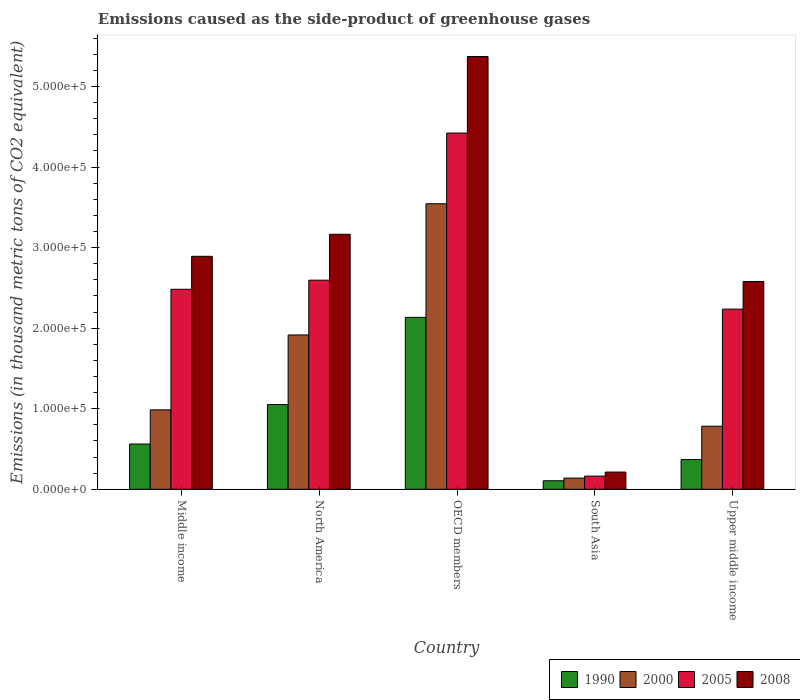How many bars are there on the 2nd tick from the left?
Offer a very short reply. 4. How many bars are there on the 4th tick from the right?
Keep it short and to the point. 4. What is the label of the 1st group of bars from the left?
Offer a terse response. Middle income. In how many cases, is the number of bars for a given country not equal to the number of legend labels?
Give a very brief answer. 0. What is the emissions caused as the side-product of greenhouse gases in 1990 in Upper middle income?
Provide a short and direct response. 3.69e+04. Across all countries, what is the maximum emissions caused as the side-product of greenhouse gases in 2008?
Your response must be concise. 5.37e+05. Across all countries, what is the minimum emissions caused as the side-product of greenhouse gases in 1990?
Make the answer very short. 1.06e+04. In which country was the emissions caused as the side-product of greenhouse gases in 2000 maximum?
Ensure brevity in your answer.  OECD members. In which country was the emissions caused as the side-product of greenhouse gases in 2000 minimum?
Your answer should be very brief. South Asia. What is the total emissions caused as the side-product of greenhouse gases in 1990 in the graph?
Give a very brief answer. 4.22e+05. What is the difference between the emissions caused as the side-product of greenhouse gases in 2000 in North America and that in South Asia?
Keep it short and to the point. 1.78e+05. What is the difference between the emissions caused as the side-product of greenhouse gases in 2000 in North America and the emissions caused as the side-product of greenhouse gases in 2005 in Upper middle income?
Provide a short and direct response. -3.21e+04. What is the average emissions caused as the side-product of greenhouse gases in 2008 per country?
Your answer should be compact. 2.84e+05. What is the difference between the emissions caused as the side-product of greenhouse gases of/in 1990 and emissions caused as the side-product of greenhouse gases of/in 2008 in Middle income?
Your answer should be compact. -2.33e+05. In how many countries, is the emissions caused as the side-product of greenhouse gases in 2005 greater than 20000 thousand metric tons?
Keep it short and to the point. 4. What is the ratio of the emissions caused as the side-product of greenhouse gases in 2005 in Middle income to that in Upper middle income?
Give a very brief answer. 1.11. Is the emissions caused as the side-product of greenhouse gases in 2005 in South Asia less than that in Upper middle income?
Provide a succinct answer. Yes. What is the difference between the highest and the second highest emissions caused as the side-product of greenhouse gases in 2005?
Provide a short and direct response. 1.13e+04. What is the difference between the highest and the lowest emissions caused as the side-product of greenhouse gases in 2005?
Your answer should be very brief. 4.26e+05. Is the sum of the emissions caused as the side-product of greenhouse gases in 1990 in North America and Upper middle income greater than the maximum emissions caused as the side-product of greenhouse gases in 2008 across all countries?
Keep it short and to the point. No. Are all the bars in the graph horizontal?
Keep it short and to the point. No. How many countries are there in the graph?
Your response must be concise. 5. Are the values on the major ticks of Y-axis written in scientific E-notation?
Keep it short and to the point. Yes. Where does the legend appear in the graph?
Make the answer very short. Bottom right. How are the legend labels stacked?
Your answer should be very brief. Horizontal. What is the title of the graph?
Your answer should be very brief. Emissions caused as the side-product of greenhouse gases. What is the label or title of the Y-axis?
Offer a very short reply. Emissions (in thousand metric tons of CO2 equivalent). What is the Emissions (in thousand metric tons of CO2 equivalent) in 1990 in Middle income?
Provide a short and direct response. 5.62e+04. What is the Emissions (in thousand metric tons of CO2 equivalent) in 2000 in Middle income?
Ensure brevity in your answer.  9.86e+04. What is the Emissions (in thousand metric tons of CO2 equivalent) in 2005 in Middle income?
Offer a very short reply. 2.48e+05. What is the Emissions (in thousand metric tons of CO2 equivalent) in 2008 in Middle income?
Provide a short and direct response. 2.89e+05. What is the Emissions (in thousand metric tons of CO2 equivalent) of 1990 in North America?
Your answer should be very brief. 1.05e+05. What is the Emissions (in thousand metric tons of CO2 equivalent) of 2000 in North America?
Your answer should be compact. 1.92e+05. What is the Emissions (in thousand metric tons of CO2 equivalent) in 2005 in North America?
Offer a very short reply. 2.60e+05. What is the Emissions (in thousand metric tons of CO2 equivalent) in 2008 in North America?
Your response must be concise. 3.17e+05. What is the Emissions (in thousand metric tons of CO2 equivalent) in 1990 in OECD members?
Offer a very short reply. 2.13e+05. What is the Emissions (in thousand metric tons of CO2 equivalent) in 2000 in OECD members?
Your response must be concise. 3.54e+05. What is the Emissions (in thousand metric tons of CO2 equivalent) in 2005 in OECD members?
Offer a very short reply. 4.42e+05. What is the Emissions (in thousand metric tons of CO2 equivalent) of 2008 in OECD members?
Ensure brevity in your answer.  5.37e+05. What is the Emissions (in thousand metric tons of CO2 equivalent) of 1990 in South Asia?
Your answer should be very brief. 1.06e+04. What is the Emissions (in thousand metric tons of CO2 equivalent) of 2000 in South Asia?
Ensure brevity in your answer.  1.39e+04. What is the Emissions (in thousand metric tons of CO2 equivalent) of 2005 in South Asia?
Keep it short and to the point. 1.64e+04. What is the Emissions (in thousand metric tons of CO2 equivalent) of 2008 in South Asia?
Provide a succinct answer. 2.14e+04. What is the Emissions (in thousand metric tons of CO2 equivalent) in 1990 in Upper middle income?
Make the answer very short. 3.69e+04. What is the Emissions (in thousand metric tons of CO2 equivalent) of 2000 in Upper middle income?
Your answer should be compact. 7.83e+04. What is the Emissions (in thousand metric tons of CO2 equivalent) in 2005 in Upper middle income?
Your answer should be compact. 2.24e+05. What is the Emissions (in thousand metric tons of CO2 equivalent) of 2008 in Upper middle income?
Offer a very short reply. 2.58e+05. Across all countries, what is the maximum Emissions (in thousand metric tons of CO2 equivalent) of 1990?
Offer a terse response. 2.13e+05. Across all countries, what is the maximum Emissions (in thousand metric tons of CO2 equivalent) in 2000?
Give a very brief answer. 3.54e+05. Across all countries, what is the maximum Emissions (in thousand metric tons of CO2 equivalent) of 2005?
Your answer should be compact. 4.42e+05. Across all countries, what is the maximum Emissions (in thousand metric tons of CO2 equivalent) in 2008?
Provide a short and direct response. 5.37e+05. Across all countries, what is the minimum Emissions (in thousand metric tons of CO2 equivalent) of 1990?
Offer a terse response. 1.06e+04. Across all countries, what is the minimum Emissions (in thousand metric tons of CO2 equivalent) of 2000?
Make the answer very short. 1.39e+04. Across all countries, what is the minimum Emissions (in thousand metric tons of CO2 equivalent) in 2005?
Provide a short and direct response. 1.64e+04. Across all countries, what is the minimum Emissions (in thousand metric tons of CO2 equivalent) of 2008?
Your answer should be compact. 2.14e+04. What is the total Emissions (in thousand metric tons of CO2 equivalent) of 1990 in the graph?
Provide a succinct answer. 4.22e+05. What is the total Emissions (in thousand metric tons of CO2 equivalent) in 2000 in the graph?
Provide a short and direct response. 7.37e+05. What is the total Emissions (in thousand metric tons of CO2 equivalent) of 2005 in the graph?
Provide a short and direct response. 1.19e+06. What is the total Emissions (in thousand metric tons of CO2 equivalent) in 2008 in the graph?
Ensure brevity in your answer.  1.42e+06. What is the difference between the Emissions (in thousand metric tons of CO2 equivalent) of 1990 in Middle income and that in North America?
Offer a very short reply. -4.90e+04. What is the difference between the Emissions (in thousand metric tons of CO2 equivalent) in 2000 in Middle income and that in North America?
Provide a short and direct response. -9.30e+04. What is the difference between the Emissions (in thousand metric tons of CO2 equivalent) in 2005 in Middle income and that in North America?
Ensure brevity in your answer.  -1.13e+04. What is the difference between the Emissions (in thousand metric tons of CO2 equivalent) of 2008 in Middle income and that in North America?
Your answer should be compact. -2.73e+04. What is the difference between the Emissions (in thousand metric tons of CO2 equivalent) in 1990 in Middle income and that in OECD members?
Your answer should be very brief. -1.57e+05. What is the difference between the Emissions (in thousand metric tons of CO2 equivalent) in 2000 in Middle income and that in OECD members?
Provide a succinct answer. -2.56e+05. What is the difference between the Emissions (in thousand metric tons of CO2 equivalent) in 2005 in Middle income and that in OECD members?
Keep it short and to the point. -1.94e+05. What is the difference between the Emissions (in thousand metric tons of CO2 equivalent) in 2008 in Middle income and that in OECD members?
Your answer should be compact. -2.48e+05. What is the difference between the Emissions (in thousand metric tons of CO2 equivalent) in 1990 in Middle income and that in South Asia?
Ensure brevity in your answer.  4.56e+04. What is the difference between the Emissions (in thousand metric tons of CO2 equivalent) of 2000 in Middle income and that in South Asia?
Make the answer very short. 8.47e+04. What is the difference between the Emissions (in thousand metric tons of CO2 equivalent) of 2005 in Middle income and that in South Asia?
Your answer should be compact. 2.32e+05. What is the difference between the Emissions (in thousand metric tons of CO2 equivalent) in 2008 in Middle income and that in South Asia?
Provide a short and direct response. 2.68e+05. What is the difference between the Emissions (in thousand metric tons of CO2 equivalent) in 1990 in Middle income and that in Upper middle income?
Keep it short and to the point. 1.93e+04. What is the difference between the Emissions (in thousand metric tons of CO2 equivalent) of 2000 in Middle income and that in Upper middle income?
Ensure brevity in your answer.  2.03e+04. What is the difference between the Emissions (in thousand metric tons of CO2 equivalent) of 2005 in Middle income and that in Upper middle income?
Your response must be concise. 2.47e+04. What is the difference between the Emissions (in thousand metric tons of CO2 equivalent) in 2008 in Middle income and that in Upper middle income?
Your response must be concise. 3.13e+04. What is the difference between the Emissions (in thousand metric tons of CO2 equivalent) of 1990 in North America and that in OECD members?
Your answer should be very brief. -1.08e+05. What is the difference between the Emissions (in thousand metric tons of CO2 equivalent) in 2000 in North America and that in OECD members?
Offer a terse response. -1.63e+05. What is the difference between the Emissions (in thousand metric tons of CO2 equivalent) in 2005 in North America and that in OECD members?
Your answer should be compact. -1.83e+05. What is the difference between the Emissions (in thousand metric tons of CO2 equivalent) in 2008 in North America and that in OECD members?
Give a very brief answer. -2.21e+05. What is the difference between the Emissions (in thousand metric tons of CO2 equivalent) of 1990 in North America and that in South Asia?
Provide a short and direct response. 9.46e+04. What is the difference between the Emissions (in thousand metric tons of CO2 equivalent) of 2000 in North America and that in South Asia?
Offer a very short reply. 1.78e+05. What is the difference between the Emissions (in thousand metric tons of CO2 equivalent) in 2005 in North America and that in South Asia?
Your response must be concise. 2.43e+05. What is the difference between the Emissions (in thousand metric tons of CO2 equivalent) of 2008 in North America and that in South Asia?
Make the answer very short. 2.95e+05. What is the difference between the Emissions (in thousand metric tons of CO2 equivalent) of 1990 in North America and that in Upper middle income?
Provide a short and direct response. 6.83e+04. What is the difference between the Emissions (in thousand metric tons of CO2 equivalent) of 2000 in North America and that in Upper middle income?
Your answer should be very brief. 1.13e+05. What is the difference between the Emissions (in thousand metric tons of CO2 equivalent) of 2005 in North America and that in Upper middle income?
Offer a very short reply. 3.59e+04. What is the difference between the Emissions (in thousand metric tons of CO2 equivalent) in 2008 in North America and that in Upper middle income?
Keep it short and to the point. 5.86e+04. What is the difference between the Emissions (in thousand metric tons of CO2 equivalent) of 1990 in OECD members and that in South Asia?
Offer a very short reply. 2.03e+05. What is the difference between the Emissions (in thousand metric tons of CO2 equivalent) in 2000 in OECD members and that in South Asia?
Ensure brevity in your answer.  3.41e+05. What is the difference between the Emissions (in thousand metric tons of CO2 equivalent) in 2005 in OECD members and that in South Asia?
Your answer should be compact. 4.26e+05. What is the difference between the Emissions (in thousand metric tons of CO2 equivalent) in 2008 in OECD members and that in South Asia?
Offer a terse response. 5.16e+05. What is the difference between the Emissions (in thousand metric tons of CO2 equivalent) in 1990 in OECD members and that in Upper middle income?
Your answer should be compact. 1.77e+05. What is the difference between the Emissions (in thousand metric tons of CO2 equivalent) of 2000 in OECD members and that in Upper middle income?
Your answer should be very brief. 2.76e+05. What is the difference between the Emissions (in thousand metric tons of CO2 equivalent) in 2005 in OECD members and that in Upper middle income?
Offer a very short reply. 2.19e+05. What is the difference between the Emissions (in thousand metric tons of CO2 equivalent) of 2008 in OECD members and that in Upper middle income?
Provide a short and direct response. 2.79e+05. What is the difference between the Emissions (in thousand metric tons of CO2 equivalent) of 1990 in South Asia and that in Upper middle income?
Provide a succinct answer. -2.63e+04. What is the difference between the Emissions (in thousand metric tons of CO2 equivalent) in 2000 in South Asia and that in Upper middle income?
Give a very brief answer. -6.44e+04. What is the difference between the Emissions (in thousand metric tons of CO2 equivalent) in 2005 in South Asia and that in Upper middle income?
Give a very brief answer. -2.07e+05. What is the difference between the Emissions (in thousand metric tons of CO2 equivalent) of 2008 in South Asia and that in Upper middle income?
Give a very brief answer. -2.37e+05. What is the difference between the Emissions (in thousand metric tons of CO2 equivalent) of 1990 in Middle income and the Emissions (in thousand metric tons of CO2 equivalent) of 2000 in North America?
Offer a terse response. -1.35e+05. What is the difference between the Emissions (in thousand metric tons of CO2 equivalent) in 1990 in Middle income and the Emissions (in thousand metric tons of CO2 equivalent) in 2005 in North America?
Make the answer very short. -2.03e+05. What is the difference between the Emissions (in thousand metric tons of CO2 equivalent) in 1990 in Middle income and the Emissions (in thousand metric tons of CO2 equivalent) in 2008 in North America?
Ensure brevity in your answer.  -2.60e+05. What is the difference between the Emissions (in thousand metric tons of CO2 equivalent) of 2000 in Middle income and the Emissions (in thousand metric tons of CO2 equivalent) of 2005 in North America?
Your answer should be compact. -1.61e+05. What is the difference between the Emissions (in thousand metric tons of CO2 equivalent) of 2000 in Middle income and the Emissions (in thousand metric tons of CO2 equivalent) of 2008 in North America?
Offer a very short reply. -2.18e+05. What is the difference between the Emissions (in thousand metric tons of CO2 equivalent) in 2005 in Middle income and the Emissions (in thousand metric tons of CO2 equivalent) in 2008 in North America?
Your answer should be compact. -6.83e+04. What is the difference between the Emissions (in thousand metric tons of CO2 equivalent) of 1990 in Middle income and the Emissions (in thousand metric tons of CO2 equivalent) of 2000 in OECD members?
Make the answer very short. -2.98e+05. What is the difference between the Emissions (in thousand metric tons of CO2 equivalent) of 1990 in Middle income and the Emissions (in thousand metric tons of CO2 equivalent) of 2005 in OECD members?
Ensure brevity in your answer.  -3.86e+05. What is the difference between the Emissions (in thousand metric tons of CO2 equivalent) in 1990 in Middle income and the Emissions (in thousand metric tons of CO2 equivalent) in 2008 in OECD members?
Keep it short and to the point. -4.81e+05. What is the difference between the Emissions (in thousand metric tons of CO2 equivalent) in 2000 in Middle income and the Emissions (in thousand metric tons of CO2 equivalent) in 2005 in OECD members?
Provide a short and direct response. -3.44e+05. What is the difference between the Emissions (in thousand metric tons of CO2 equivalent) of 2000 in Middle income and the Emissions (in thousand metric tons of CO2 equivalent) of 2008 in OECD members?
Give a very brief answer. -4.39e+05. What is the difference between the Emissions (in thousand metric tons of CO2 equivalent) of 2005 in Middle income and the Emissions (in thousand metric tons of CO2 equivalent) of 2008 in OECD members?
Give a very brief answer. -2.89e+05. What is the difference between the Emissions (in thousand metric tons of CO2 equivalent) of 1990 in Middle income and the Emissions (in thousand metric tons of CO2 equivalent) of 2000 in South Asia?
Your answer should be very brief. 4.23e+04. What is the difference between the Emissions (in thousand metric tons of CO2 equivalent) in 1990 in Middle income and the Emissions (in thousand metric tons of CO2 equivalent) in 2005 in South Asia?
Ensure brevity in your answer.  3.98e+04. What is the difference between the Emissions (in thousand metric tons of CO2 equivalent) of 1990 in Middle income and the Emissions (in thousand metric tons of CO2 equivalent) of 2008 in South Asia?
Your answer should be very brief. 3.48e+04. What is the difference between the Emissions (in thousand metric tons of CO2 equivalent) in 2000 in Middle income and the Emissions (in thousand metric tons of CO2 equivalent) in 2005 in South Asia?
Make the answer very short. 8.22e+04. What is the difference between the Emissions (in thousand metric tons of CO2 equivalent) in 2000 in Middle income and the Emissions (in thousand metric tons of CO2 equivalent) in 2008 in South Asia?
Your answer should be very brief. 7.72e+04. What is the difference between the Emissions (in thousand metric tons of CO2 equivalent) in 2005 in Middle income and the Emissions (in thousand metric tons of CO2 equivalent) in 2008 in South Asia?
Your response must be concise. 2.27e+05. What is the difference between the Emissions (in thousand metric tons of CO2 equivalent) in 1990 in Middle income and the Emissions (in thousand metric tons of CO2 equivalent) in 2000 in Upper middle income?
Provide a succinct answer. -2.21e+04. What is the difference between the Emissions (in thousand metric tons of CO2 equivalent) in 1990 in Middle income and the Emissions (in thousand metric tons of CO2 equivalent) in 2005 in Upper middle income?
Your answer should be compact. -1.67e+05. What is the difference between the Emissions (in thousand metric tons of CO2 equivalent) of 1990 in Middle income and the Emissions (in thousand metric tons of CO2 equivalent) of 2008 in Upper middle income?
Ensure brevity in your answer.  -2.02e+05. What is the difference between the Emissions (in thousand metric tons of CO2 equivalent) in 2000 in Middle income and the Emissions (in thousand metric tons of CO2 equivalent) in 2005 in Upper middle income?
Offer a very short reply. -1.25e+05. What is the difference between the Emissions (in thousand metric tons of CO2 equivalent) in 2000 in Middle income and the Emissions (in thousand metric tons of CO2 equivalent) in 2008 in Upper middle income?
Ensure brevity in your answer.  -1.59e+05. What is the difference between the Emissions (in thousand metric tons of CO2 equivalent) in 2005 in Middle income and the Emissions (in thousand metric tons of CO2 equivalent) in 2008 in Upper middle income?
Your answer should be compact. -9667. What is the difference between the Emissions (in thousand metric tons of CO2 equivalent) in 1990 in North America and the Emissions (in thousand metric tons of CO2 equivalent) in 2000 in OECD members?
Ensure brevity in your answer.  -2.49e+05. What is the difference between the Emissions (in thousand metric tons of CO2 equivalent) of 1990 in North America and the Emissions (in thousand metric tons of CO2 equivalent) of 2005 in OECD members?
Provide a succinct answer. -3.37e+05. What is the difference between the Emissions (in thousand metric tons of CO2 equivalent) of 1990 in North America and the Emissions (in thousand metric tons of CO2 equivalent) of 2008 in OECD members?
Provide a succinct answer. -4.32e+05. What is the difference between the Emissions (in thousand metric tons of CO2 equivalent) of 2000 in North America and the Emissions (in thousand metric tons of CO2 equivalent) of 2005 in OECD members?
Your answer should be very brief. -2.51e+05. What is the difference between the Emissions (in thousand metric tons of CO2 equivalent) of 2000 in North America and the Emissions (in thousand metric tons of CO2 equivalent) of 2008 in OECD members?
Keep it short and to the point. -3.46e+05. What is the difference between the Emissions (in thousand metric tons of CO2 equivalent) in 2005 in North America and the Emissions (in thousand metric tons of CO2 equivalent) in 2008 in OECD members?
Offer a terse response. -2.78e+05. What is the difference between the Emissions (in thousand metric tons of CO2 equivalent) in 1990 in North America and the Emissions (in thousand metric tons of CO2 equivalent) in 2000 in South Asia?
Give a very brief answer. 9.13e+04. What is the difference between the Emissions (in thousand metric tons of CO2 equivalent) of 1990 in North America and the Emissions (in thousand metric tons of CO2 equivalent) of 2005 in South Asia?
Offer a terse response. 8.88e+04. What is the difference between the Emissions (in thousand metric tons of CO2 equivalent) of 1990 in North America and the Emissions (in thousand metric tons of CO2 equivalent) of 2008 in South Asia?
Provide a short and direct response. 8.38e+04. What is the difference between the Emissions (in thousand metric tons of CO2 equivalent) in 2000 in North America and the Emissions (in thousand metric tons of CO2 equivalent) in 2005 in South Asia?
Offer a very short reply. 1.75e+05. What is the difference between the Emissions (in thousand metric tons of CO2 equivalent) in 2000 in North America and the Emissions (in thousand metric tons of CO2 equivalent) in 2008 in South Asia?
Your answer should be very brief. 1.70e+05. What is the difference between the Emissions (in thousand metric tons of CO2 equivalent) in 2005 in North America and the Emissions (in thousand metric tons of CO2 equivalent) in 2008 in South Asia?
Provide a short and direct response. 2.38e+05. What is the difference between the Emissions (in thousand metric tons of CO2 equivalent) in 1990 in North America and the Emissions (in thousand metric tons of CO2 equivalent) in 2000 in Upper middle income?
Your response must be concise. 2.69e+04. What is the difference between the Emissions (in thousand metric tons of CO2 equivalent) of 1990 in North America and the Emissions (in thousand metric tons of CO2 equivalent) of 2005 in Upper middle income?
Keep it short and to the point. -1.18e+05. What is the difference between the Emissions (in thousand metric tons of CO2 equivalent) in 1990 in North America and the Emissions (in thousand metric tons of CO2 equivalent) in 2008 in Upper middle income?
Make the answer very short. -1.53e+05. What is the difference between the Emissions (in thousand metric tons of CO2 equivalent) of 2000 in North America and the Emissions (in thousand metric tons of CO2 equivalent) of 2005 in Upper middle income?
Offer a very short reply. -3.21e+04. What is the difference between the Emissions (in thousand metric tons of CO2 equivalent) of 2000 in North America and the Emissions (in thousand metric tons of CO2 equivalent) of 2008 in Upper middle income?
Ensure brevity in your answer.  -6.64e+04. What is the difference between the Emissions (in thousand metric tons of CO2 equivalent) in 2005 in North America and the Emissions (in thousand metric tons of CO2 equivalent) in 2008 in Upper middle income?
Offer a very short reply. 1628.2. What is the difference between the Emissions (in thousand metric tons of CO2 equivalent) of 1990 in OECD members and the Emissions (in thousand metric tons of CO2 equivalent) of 2000 in South Asia?
Make the answer very short. 2.00e+05. What is the difference between the Emissions (in thousand metric tons of CO2 equivalent) in 1990 in OECD members and the Emissions (in thousand metric tons of CO2 equivalent) in 2005 in South Asia?
Offer a very short reply. 1.97e+05. What is the difference between the Emissions (in thousand metric tons of CO2 equivalent) of 1990 in OECD members and the Emissions (in thousand metric tons of CO2 equivalent) of 2008 in South Asia?
Provide a succinct answer. 1.92e+05. What is the difference between the Emissions (in thousand metric tons of CO2 equivalent) in 2000 in OECD members and the Emissions (in thousand metric tons of CO2 equivalent) in 2005 in South Asia?
Your answer should be very brief. 3.38e+05. What is the difference between the Emissions (in thousand metric tons of CO2 equivalent) in 2000 in OECD members and the Emissions (in thousand metric tons of CO2 equivalent) in 2008 in South Asia?
Offer a terse response. 3.33e+05. What is the difference between the Emissions (in thousand metric tons of CO2 equivalent) of 2005 in OECD members and the Emissions (in thousand metric tons of CO2 equivalent) of 2008 in South Asia?
Provide a succinct answer. 4.21e+05. What is the difference between the Emissions (in thousand metric tons of CO2 equivalent) in 1990 in OECD members and the Emissions (in thousand metric tons of CO2 equivalent) in 2000 in Upper middle income?
Your response must be concise. 1.35e+05. What is the difference between the Emissions (in thousand metric tons of CO2 equivalent) in 1990 in OECD members and the Emissions (in thousand metric tons of CO2 equivalent) in 2005 in Upper middle income?
Ensure brevity in your answer.  -1.02e+04. What is the difference between the Emissions (in thousand metric tons of CO2 equivalent) of 1990 in OECD members and the Emissions (in thousand metric tons of CO2 equivalent) of 2008 in Upper middle income?
Offer a very short reply. -4.45e+04. What is the difference between the Emissions (in thousand metric tons of CO2 equivalent) of 2000 in OECD members and the Emissions (in thousand metric tons of CO2 equivalent) of 2005 in Upper middle income?
Keep it short and to the point. 1.31e+05. What is the difference between the Emissions (in thousand metric tons of CO2 equivalent) of 2000 in OECD members and the Emissions (in thousand metric tons of CO2 equivalent) of 2008 in Upper middle income?
Make the answer very short. 9.65e+04. What is the difference between the Emissions (in thousand metric tons of CO2 equivalent) of 2005 in OECD members and the Emissions (in thousand metric tons of CO2 equivalent) of 2008 in Upper middle income?
Your answer should be compact. 1.84e+05. What is the difference between the Emissions (in thousand metric tons of CO2 equivalent) of 1990 in South Asia and the Emissions (in thousand metric tons of CO2 equivalent) of 2000 in Upper middle income?
Your answer should be very brief. -6.77e+04. What is the difference between the Emissions (in thousand metric tons of CO2 equivalent) of 1990 in South Asia and the Emissions (in thousand metric tons of CO2 equivalent) of 2005 in Upper middle income?
Ensure brevity in your answer.  -2.13e+05. What is the difference between the Emissions (in thousand metric tons of CO2 equivalent) of 1990 in South Asia and the Emissions (in thousand metric tons of CO2 equivalent) of 2008 in Upper middle income?
Give a very brief answer. -2.47e+05. What is the difference between the Emissions (in thousand metric tons of CO2 equivalent) in 2000 in South Asia and the Emissions (in thousand metric tons of CO2 equivalent) in 2005 in Upper middle income?
Offer a very short reply. -2.10e+05. What is the difference between the Emissions (in thousand metric tons of CO2 equivalent) in 2000 in South Asia and the Emissions (in thousand metric tons of CO2 equivalent) in 2008 in Upper middle income?
Your response must be concise. -2.44e+05. What is the difference between the Emissions (in thousand metric tons of CO2 equivalent) in 2005 in South Asia and the Emissions (in thousand metric tons of CO2 equivalent) in 2008 in Upper middle income?
Provide a succinct answer. -2.42e+05. What is the average Emissions (in thousand metric tons of CO2 equivalent) of 1990 per country?
Offer a terse response. 8.45e+04. What is the average Emissions (in thousand metric tons of CO2 equivalent) of 2000 per country?
Your answer should be very brief. 1.47e+05. What is the average Emissions (in thousand metric tons of CO2 equivalent) of 2005 per country?
Provide a short and direct response. 2.38e+05. What is the average Emissions (in thousand metric tons of CO2 equivalent) of 2008 per country?
Ensure brevity in your answer.  2.84e+05. What is the difference between the Emissions (in thousand metric tons of CO2 equivalent) in 1990 and Emissions (in thousand metric tons of CO2 equivalent) in 2000 in Middle income?
Your answer should be very brief. -4.24e+04. What is the difference between the Emissions (in thousand metric tons of CO2 equivalent) of 1990 and Emissions (in thousand metric tons of CO2 equivalent) of 2005 in Middle income?
Provide a short and direct response. -1.92e+05. What is the difference between the Emissions (in thousand metric tons of CO2 equivalent) in 1990 and Emissions (in thousand metric tons of CO2 equivalent) in 2008 in Middle income?
Your answer should be compact. -2.33e+05. What is the difference between the Emissions (in thousand metric tons of CO2 equivalent) in 2000 and Emissions (in thousand metric tons of CO2 equivalent) in 2005 in Middle income?
Offer a terse response. -1.50e+05. What is the difference between the Emissions (in thousand metric tons of CO2 equivalent) of 2000 and Emissions (in thousand metric tons of CO2 equivalent) of 2008 in Middle income?
Make the answer very short. -1.91e+05. What is the difference between the Emissions (in thousand metric tons of CO2 equivalent) in 2005 and Emissions (in thousand metric tons of CO2 equivalent) in 2008 in Middle income?
Ensure brevity in your answer.  -4.09e+04. What is the difference between the Emissions (in thousand metric tons of CO2 equivalent) in 1990 and Emissions (in thousand metric tons of CO2 equivalent) in 2000 in North America?
Your answer should be compact. -8.64e+04. What is the difference between the Emissions (in thousand metric tons of CO2 equivalent) of 1990 and Emissions (in thousand metric tons of CO2 equivalent) of 2005 in North America?
Provide a short and direct response. -1.54e+05. What is the difference between the Emissions (in thousand metric tons of CO2 equivalent) of 1990 and Emissions (in thousand metric tons of CO2 equivalent) of 2008 in North America?
Make the answer very short. -2.11e+05. What is the difference between the Emissions (in thousand metric tons of CO2 equivalent) of 2000 and Emissions (in thousand metric tons of CO2 equivalent) of 2005 in North America?
Ensure brevity in your answer.  -6.80e+04. What is the difference between the Emissions (in thousand metric tons of CO2 equivalent) of 2000 and Emissions (in thousand metric tons of CO2 equivalent) of 2008 in North America?
Provide a short and direct response. -1.25e+05. What is the difference between the Emissions (in thousand metric tons of CO2 equivalent) in 2005 and Emissions (in thousand metric tons of CO2 equivalent) in 2008 in North America?
Your answer should be compact. -5.70e+04. What is the difference between the Emissions (in thousand metric tons of CO2 equivalent) in 1990 and Emissions (in thousand metric tons of CO2 equivalent) in 2000 in OECD members?
Provide a short and direct response. -1.41e+05. What is the difference between the Emissions (in thousand metric tons of CO2 equivalent) of 1990 and Emissions (in thousand metric tons of CO2 equivalent) of 2005 in OECD members?
Provide a succinct answer. -2.29e+05. What is the difference between the Emissions (in thousand metric tons of CO2 equivalent) in 1990 and Emissions (in thousand metric tons of CO2 equivalent) in 2008 in OECD members?
Provide a short and direct response. -3.24e+05. What is the difference between the Emissions (in thousand metric tons of CO2 equivalent) in 2000 and Emissions (in thousand metric tons of CO2 equivalent) in 2005 in OECD members?
Provide a short and direct response. -8.78e+04. What is the difference between the Emissions (in thousand metric tons of CO2 equivalent) of 2000 and Emissions (in thousand metric tons of CO2 equivalent) of 2008 in OECD members?
Your answer should be very brief. -1.83e+05. What is the difference between the Emissions (in thousand metric tons of CO2 equivalent) of 2005 and Emissions (in thousand metric tons of CO2 equivalent) of 2008 in OECD members?
Your answer should be compact. -9.50e+04. What is the difference between the Emissions (in thousand metric tons of CO2 equivalent) in 1990 and Emissions (in thousand metric tons of CO2 equivalent) in 2000 in South Asia?
Offer a terse response. -3325.3. What is the difference between the Emissions (in thousand metric tons of CO2 equivalent) in 1990 and Emissions (in thousand metric tons of CO2 equivalent) in 2005 in South Asia?
Provide a short and direct response. -5786.5. What is the difference between the Emissions (in thousand metric tons of CO2 equivalent) in 1990 and Emissions (in thousand metric tons of CO2 equivalent) in 2008 in South Asia?
Provide a succinct answer. -1.08e+04. What is the difference between the Emissions (in thousand metric tons of CO2 equivalent) of 2000 and Emissions (in thousand metric tons of CO2 equivalent) of 2005 in South Asia?
Give a very brief answer. -2461.2. What is the difference between the Emissions (in thousand metric tons of CO2 equivalent) of 2000 and Emissions (in thousand metric tons of CO2 equivalent) of 2008 in South Asia?
Keep it short and to the point. -7460.6. What is the difference between the Emissions (in thousand metric tons of CO2 equivalent) of 2005 and Emissions (in thousand metric tons of CO2 equivalent) of 2008 in South Asia?
Provide a succinct answer. -4999.4. What is the difference between the Emissions (in thousand metric tons of CO2 equivalent) of 1990 and Emissions (in thousand metric tons of CO2 equivalent) of 2000 in Upper middle income?
Your response must be concise. -4.14e+04. What is the difference between the Emissions (in thousand metric tons of CO2 equivalent) of 1990 and Emissions (in thousand metric tons of CO2 equivalent) of 2005 in Upper middle income?
Your answer should be compact. -1.87e+05. What is the difference between the Emissions (in thousand metric tons of CO2 equivalent) in 1990 and Emissions (in thousand metric tons of CO2 equivalent) in 2008 in Upper middle income?
Make the answer very short. -2.21e+05. What is the difference between the Emissions (in thousand metric tons of CO2 equivalent) of 2000 and Emissions (in thousand metric tons of CO2 equivalent) of 2005 in Upper middle income?
Offer a terse response. -1.45e+05. What is the difference between the Emissions (in thousand metric tons of CO2 equivalent) of 2000 and Emissions (in thousand metric tons of CO2 equivalent) of 2008 in Upper middle income?
Your answer should be very brief. -1.80e+05. What is the difference between the Emissions (in thousand metric tons of CO2 equivalent) in 2005 and Emissions (in thousand metric tons of CO2 equivalent) in 2008 in Upper middle income?
Offer a very short reply. -3.43e+04. What is the ratio of the Emissions (in thousand metric tons of CO2 equivalent) of 1990 in Middle income to that in North America?
Your answer should be very brief. 0.53. What is the ratio of the Emissions (in thousand metric tons of CO2 equivalent) of 2000 in Middle income to that in North America?
Make the answer very short. 0.51. What is the ratio of the Emissions (in thousand metric tons of CO2 equivalent) in 2005 in Middle income to that in North America?
Provide a short and direct response. 0.96. What is the ratio of the Emissions (in thousand metric tons of CO2 equivalent) of 2008 in Middle income to that in North America?
Make the answer very short. 0.91. What is the ratio of the Emissions (in thousand metric tons of CO2 equivalent) of 1990 in Middle income to that in OECD members?
Your response must be concise. 0.26. What is the ratio of the Emissions (in thousand metric tons of CO2 equivalent) of 2000 in Middle income to that in OECD members?
Make the answer very short. 0.28. What is the ratio of the Emissions (in thousand metric tons of CO2 equivalent) of 2005 in Middle income to that in OECD members?
Ensure brevity in your answer.  0.56. What is the ratio of the Emissions (in thousand metric tons of CO2 equivalent) in 2008 in Middle income to that in OECD members?
Ensure brevity in your answer.  0.54. What is the ratio of the Emissions (in thousand metric tons of CO2 equivalent) of 1990 in Middle income to that in South Asia?
Make the answer very short. 5.31. What is the ratio of the Emissions (in thousand metric tons of CO2 equivalent) in 2000 in Middle income to that in South Asia?
Your answer should be very brief. 7.09. What is the ratio of the Emissions (in thousand metric tons of CO2 equivalent) of 2005 in Middle income to that in South Asia?
Keep it short and to the point. 15.18. What is the ratio of the Emissions (in thousand metric tons of CO2 equivalent) in 2008 in Middle income to that in South Asia?
Provide a succinct answer. 13.54. What is the ratio of the Emissions (in thousand metric tons of CO2 equivalent) in 1990 in Middle income to that in Upper middle income?
Provide a short and direct response. 1.52. What is the ratio of the Emissions (in thousand metric tons of CO2 equivalent) in 2000 in Middle income to that in Upper middle income?
Provide a succinct answer. 1.26. What is the ratio of the Emissions (in thousand metric tons of CO2 equivalent) of 2005 in Middle income to that in Upper middle income?
Your response must be concise. 1.11. What is the ratio of the Emissions (in thousand metric tons of CO2 equivalent) in 2008 in Middle income to that in Upper middle income?
Your answer should be compact. 1.12. What is the ratio of the Emissions (in thousand metric tons of CO2 equivalent) in 1990 in North America to that in OECD members?
Keep it short and to the point. 0.49. What is the ratio of the Emissions (in thousand metric tons of CO2 equivalent) of 2000 in North America to that in OECD members?
Give a very brief answer. 0.54. What is the ratio of the Emissions (in thousand metric tons of CO2 equivalent) in 2005 in North America to that in OECD members?
Provide a short and direct response. 0.59. What is the ratio of the Emissions (in thousand metric tons of CO2 equivalent) in 2008 in North America to that in OECD members?
Ensure brevity in your answer.  0.59. What is the ratio of the Emissions (in thousand metric tons of CO2 equivalent) in 1990 in North America to that in South Asia?
Offer a very short reply. 9.95. What is the ratio of the Emissions (in thousand metric tons of CO2 equivalent) of 2000 in North America to that in South Asia?
Your response must be concise. 13.79. What is the ratio of the Emissions (in thousand metric tons of CO2 equivalent) of 2005 in North America to that in South Asia?
Make the answer very short. 15.87. What is the ratio of the Emissions (in thousand metric tons of CO2 equivalent) in 2008 in North America to that in South Asia?
Make the answer very short. 14.82. What is the ratio of the Emissions (in thousand metric tons of CO2 equivalent) of 1990 in North America to that in Upper middle income?
Offer a very short reply. 2.85. What is the ratio of the Emissions (in thousand metric tons of CO2 equivalent) of 2000 in North America to that in Upper middle income?
Your answer should be compact. 2.45. What is the ratio of the Emissions (in thousand metric tons of CO2 equivalent) in 2005 in North America to that in Upper middle income?
Give a very brief answer. 1.16. What is the ratio of the Emissions (in thousand metric tons of CO2 equivalent) in 2008 in North America to that in Upper middle income?
Keep it short and to the point. 1.23. What is the ratio of the Emissions (in thousand metric tons of CO2 equivalent) of 1990 in OECD members to that in South Asia?
Provide a short and direct response. 20.19. What is the ratio of the Emissions (in thousand metric tons of CO2 equivalent) of 2000 in OECD members to that in South Asia?
Offer a terse response. 25.51. What is the ratio of the Emissions (in thousand metric tons of CO2 equivalent) in 2005 in OECD members to that in South Asia?
Provide a succinct answer. 27.03. What is the ratio of the Emissions (in thousand metric tons of CO2 equivalent) in 2008 in OECD members to that in South Asia?
Your answer should be compact. 25.15. What is the ratio of the Emissions (in thousand metric tons of CO2 equivalent) in 1990 in OECD members to that in Upper middle income?
Offer a terse response. 5.79. What is the ratio of the Emissions (in thousand metric tons of CO2 equivalent) of 2000 in OECD members to that in Upper middle income?
Give a very brief answer. 4.53. What is the ratio of the Emissions (in thousand metric tons of CO2 equivalent) of 2005 in OECD members to that in Upper middle income?
Your response must be concise. 1.98. What is the ratio of the Emissions (in thousand metric tons of CO2 equivalent) in 2008 in OECD members to that in Upper middle income?
Your answer should be very brief. 2.08. What is the ratio of the Emissions (in thousand metric tons of CO2 equivalent) of 1990 in South Asia to that in Upper middle income?
Your response must be concise. 0.29. What is the ratio of the Emissions (in thousand metric tons of CO2 equivalent) in 2000 in South Asia to that in Upper middle income?
Keep it short and to the point. 0.18. What is the ratio of the Emissions (in thousand metric tons of CO2 equivalent) of 2005 in South Asia to that in Upper middle income?
Your answer should be compact. 0.07. What is the ratio of the Emissions (in thousand metric tons of CO2 equivalent) of 2008 in South Asia to that in Upper middle income?
Offer a very short reply. 0.08. What is the difference between the highest and the second highest Emissions (in thousand metric tons of CO2 equivalent) in 1990?
Offer a very short reply. 1.08e+05. What is the difference between the highest and the second highest Emissions (in thousand metric tons of CO2 equivalent) of 2000?
Your answer should be compact. 1.63e+05. What is the difference between the highest and the second highest Emissions (in thousand metric tons of CO2 equivalent) in 2005?
Provide a short and direct response. 1.83e+05. What is the difference between the highest and the second highest Emissions (in thousand metric tons of CO2 equivalent) in 2008?
Ensure brevity in your answer.  2.21e+05. What is the difference between the highest and the lowest Emissions (in thousand metric tons of CO2 equivalent) in 1990?
Your answer should be compact. 2.03e+05. What is the difference between the highest and the lowest Emissions (in thousand metric tons of CO2 equivalent) in 2000?
Offer a very short reply. 3.41e+05. What is the difference between the highest and the lowest Emissions (in thousand metric tons of CO2 equivalent) in 2005?
Ensure brevity in your answer.  4.26e+05. What is the difference between the highest and the lowest Emissions (in thousand metric tons of CO2 equivalent) in 2008?
Your response must be concise. 5.16e+05. 